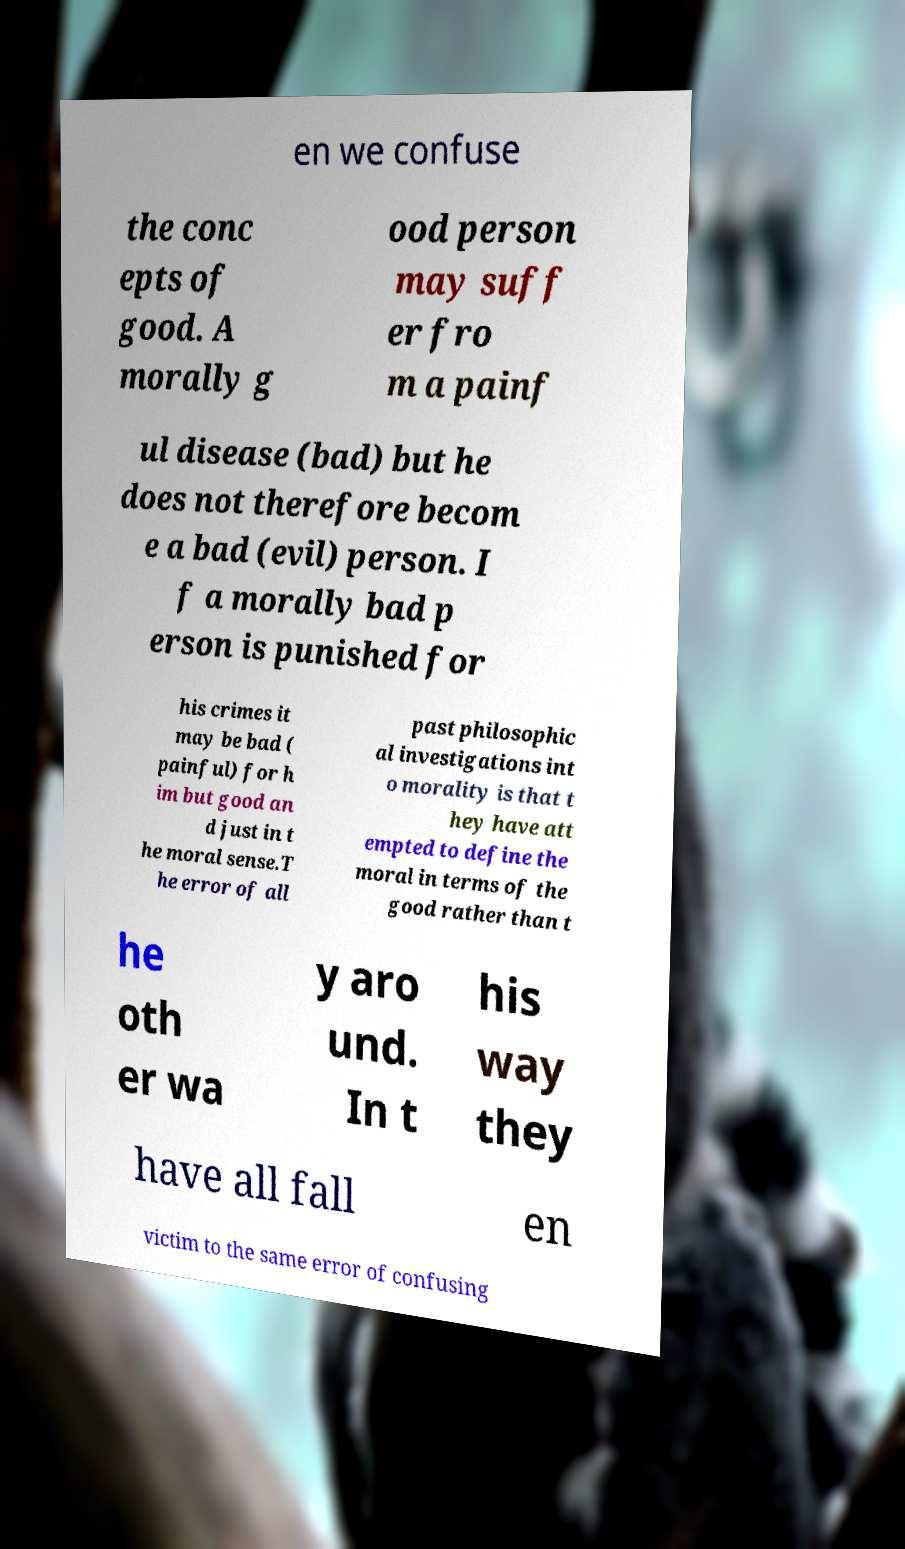I need the written content from this picture converted into text. Can you do that? en we confuse the conc epts of good. A morally g ood person may suff er fro m a painf ul disease (bad) but he does not therefore becom e a bad (evil) person. I f a morally bad p erson is punished for his crimes it may be bad ( painful) for h im but good an d just in t he moral sense.T he error of all past philosophic al investigations int o morality is that t hey have att empted to define the moral in terms of the good rather than t he oth er wa y aro und. In t his way they have all fall en victim to the same error of confusing 